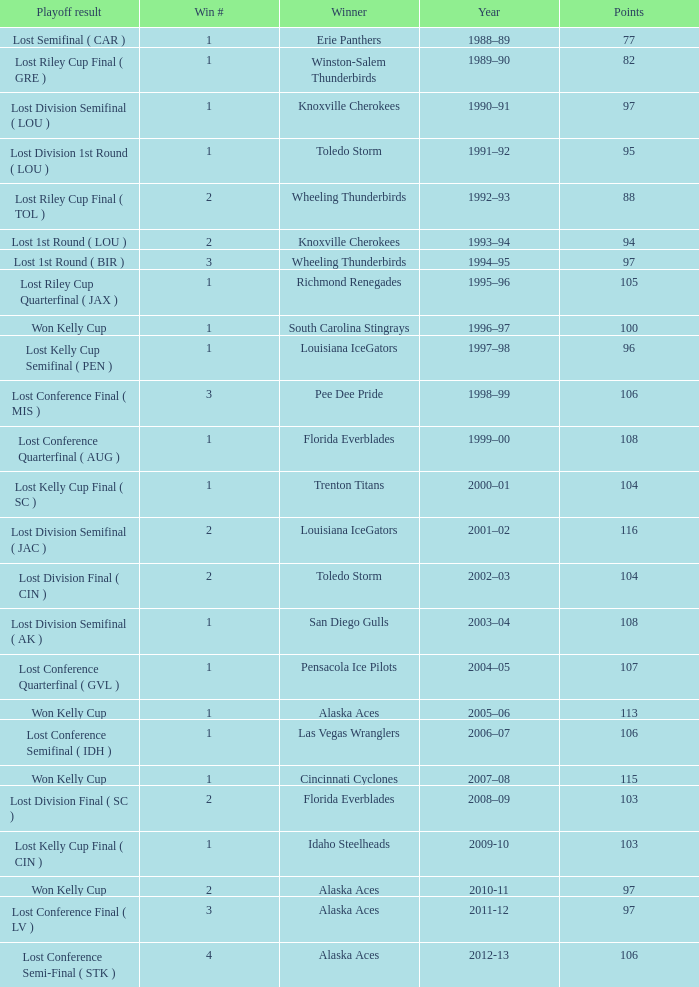What is the highest Win #, when Winner is "Knoxville Cherokees", when Playoff Result is "Lost 1st Round ( LOU )", and when Points is less than 94? None. 